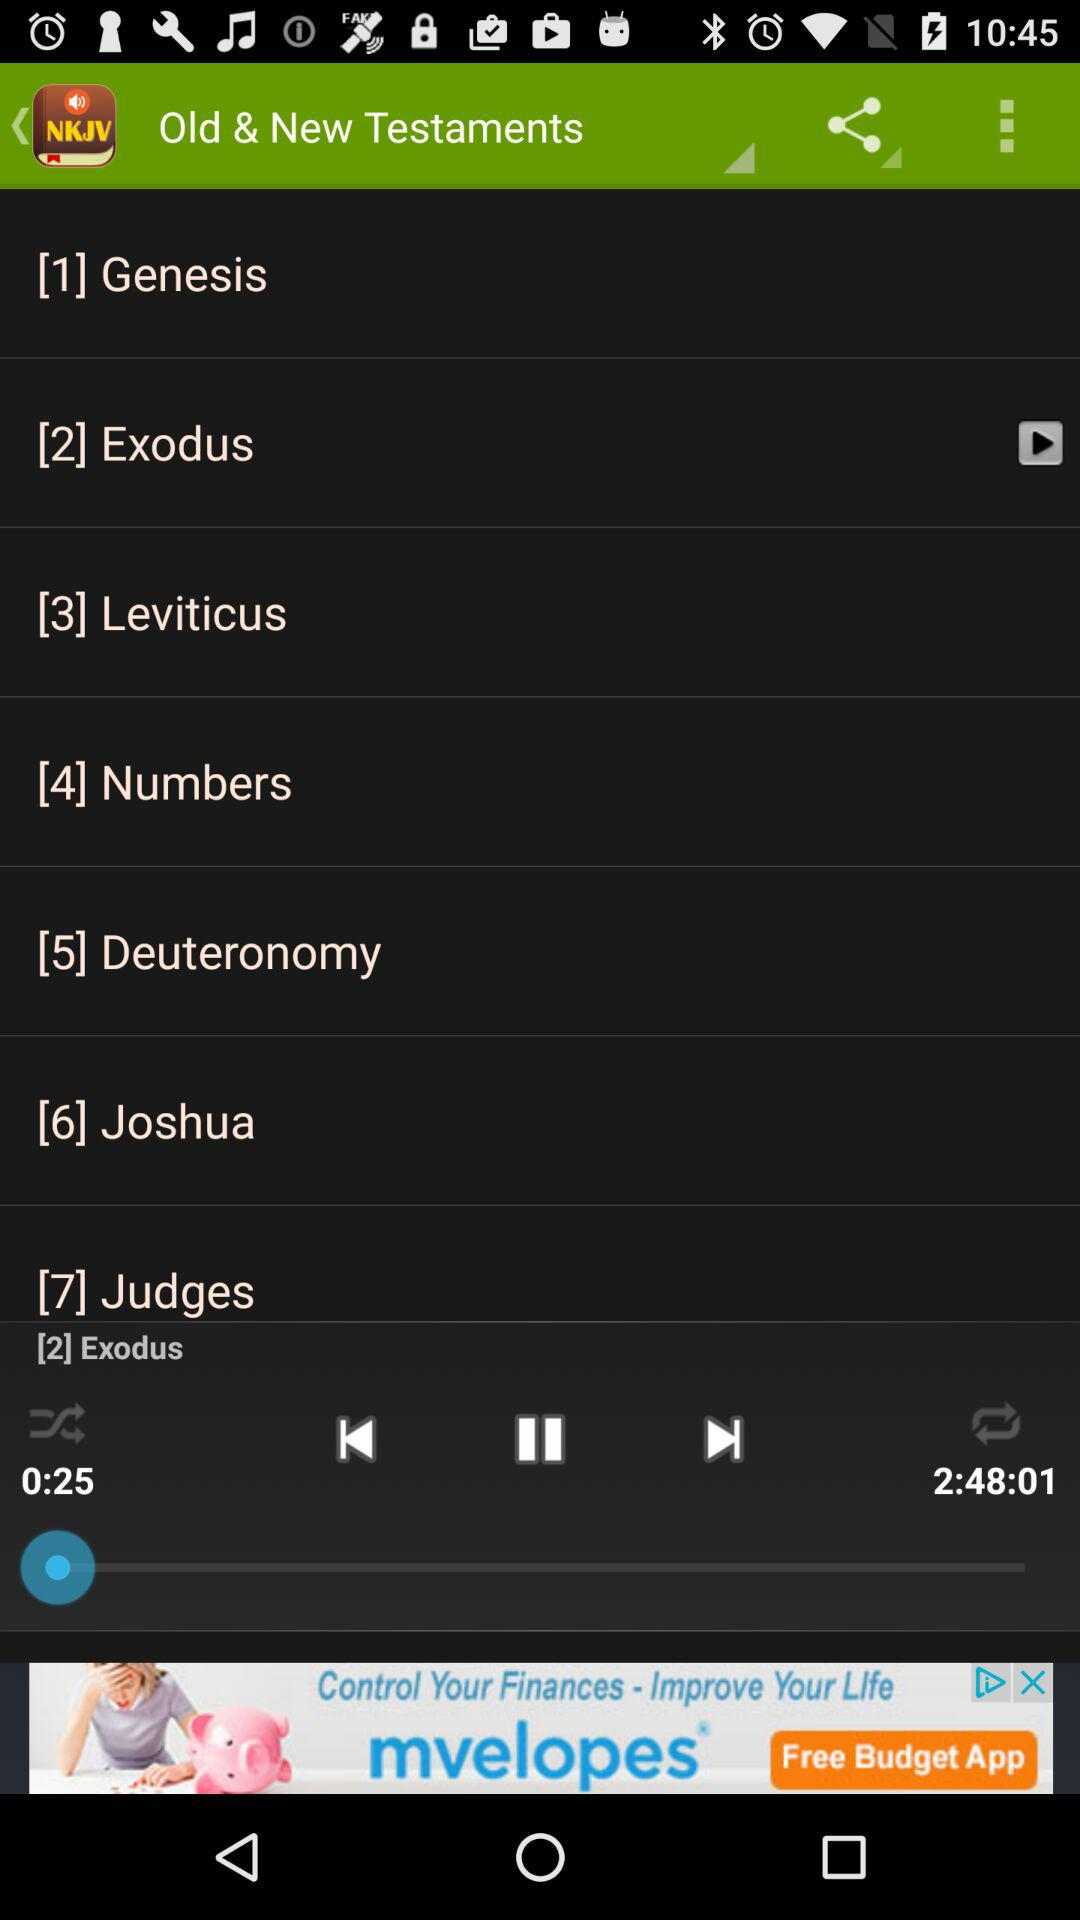At number 5, which option is present? The option is "Deuteronomy". 